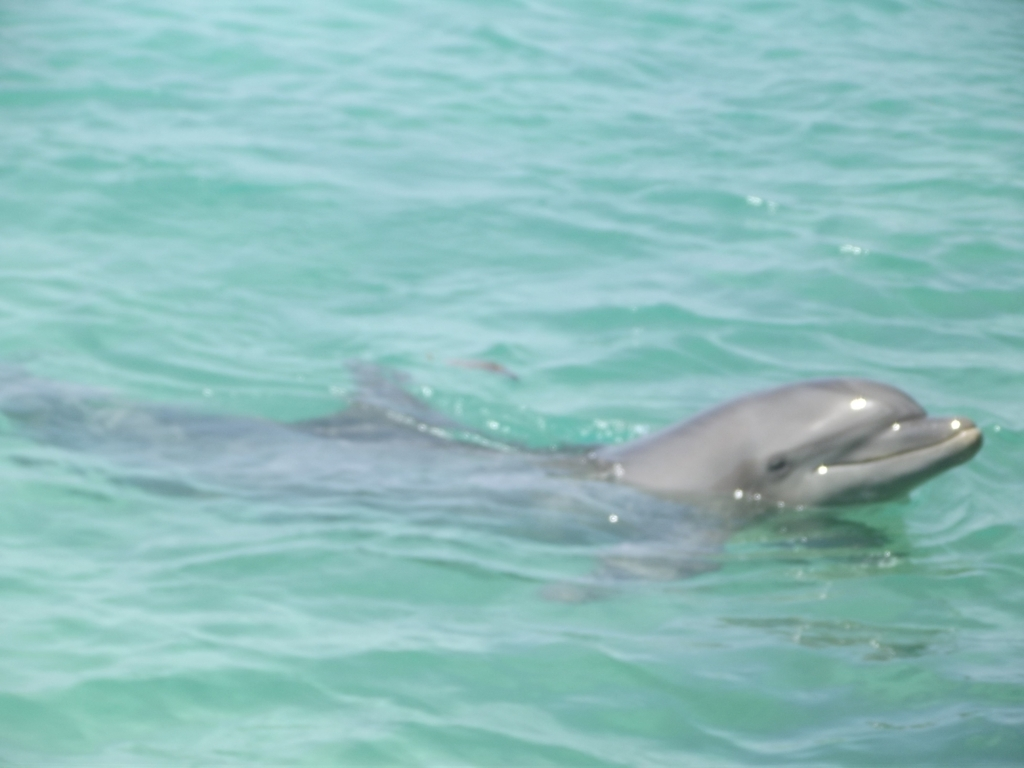Can you describe the animal in the photo and its environment? Certainly! In the image, we see a dolphin swimming in clear, turquoise water. Dolphins are highly intelligent marine mammals known for their playful behavior and agility in water. The environment seems to be a natural habitat - possibly a lagoon or a calm area of an ocean, which is typical for these creatures to frolic and socialize in. 